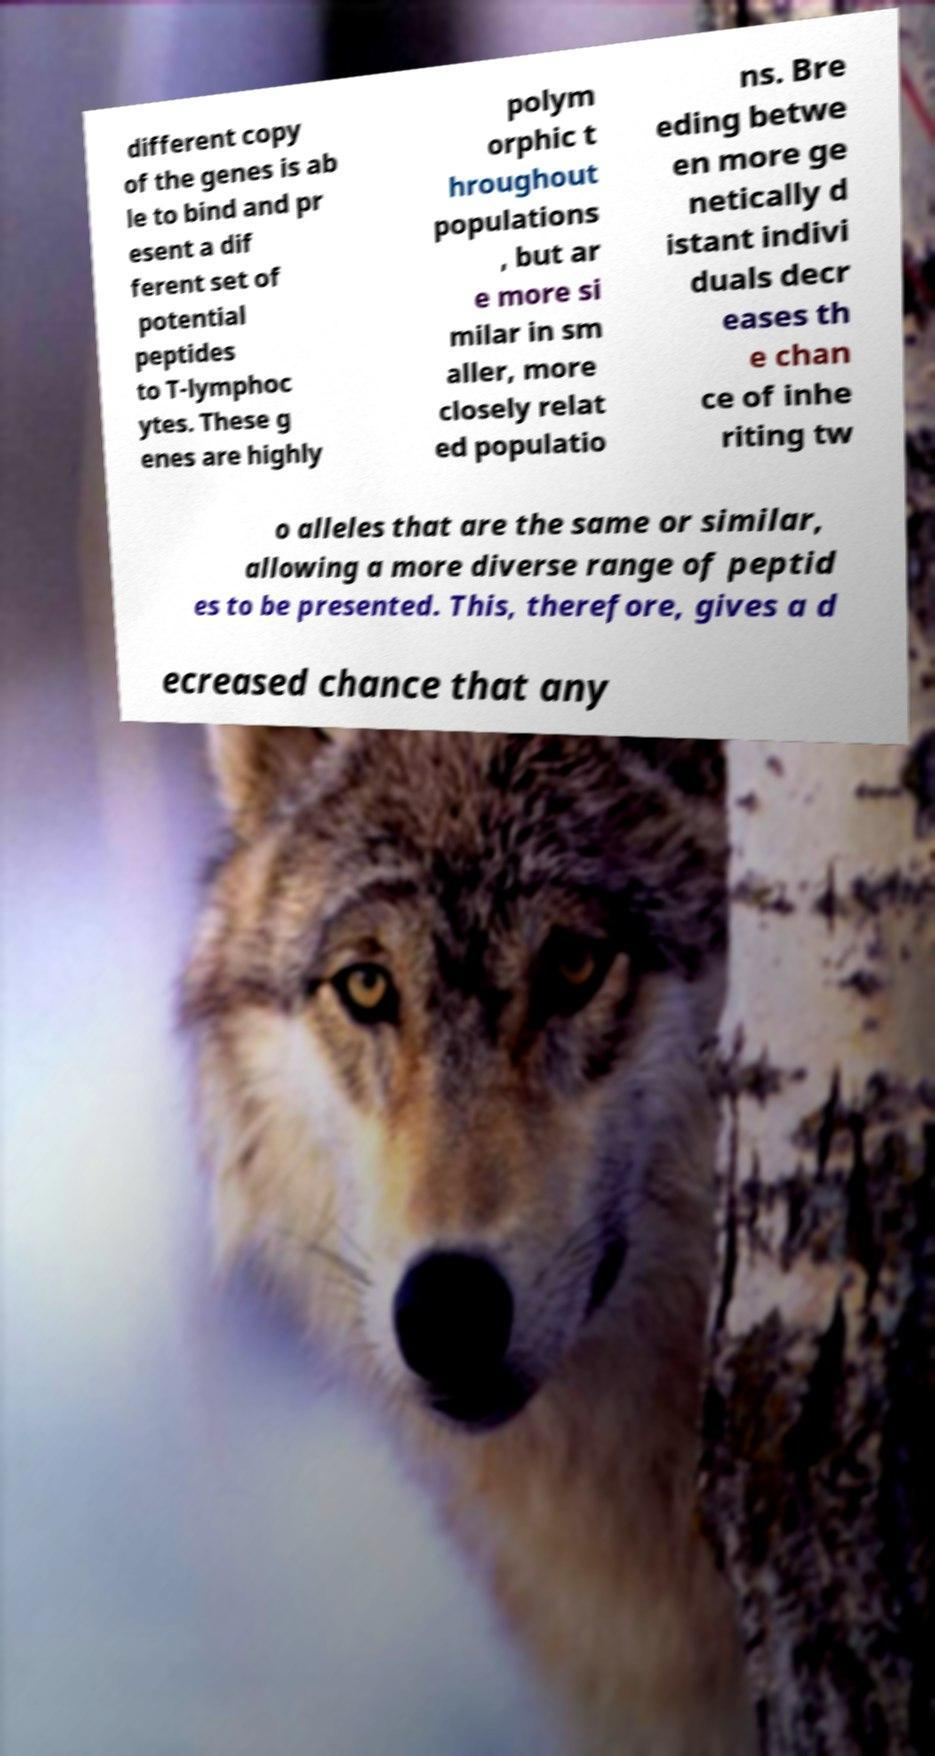For documentation purposes, I need the text within this image transcribed. Could you provide that? different copy of the genes is ab le to bind and pr esent a dif ferent set of potential peptides to T-lymphoc ytes. These g enes are highly polym orphic t hroughout populations , but ar e more si milar in sm aller, more closely relat ed populatio ns. Bre eding betwe en more ge netically d istant indivi duals decr eases th e chan ce of inhe riting tw o alleles that are the same or similar, allowing a more diverse range of peptid es to be presented. This, therefore, gives a d ecreased chance that any 